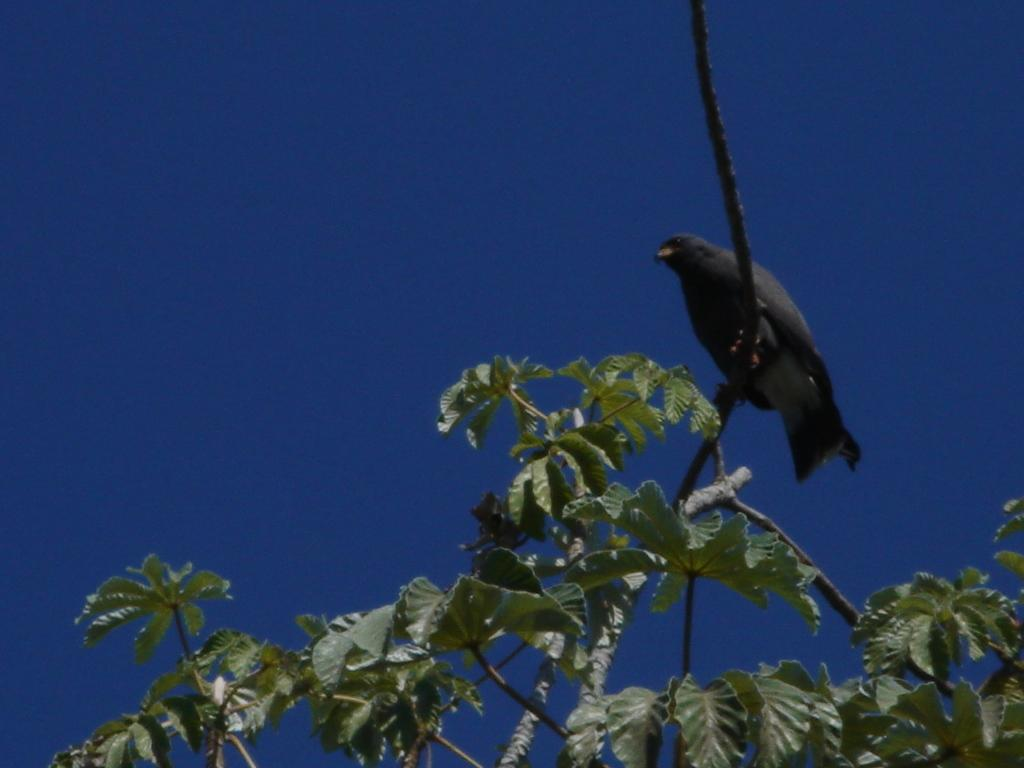What is present in the picture? There is a tree in the picture. How much of the tree can be seen? A part of the tree is visible. What else can be seen in the background? There is a gray bird in the background. What is the color of the sky in the picture? The sky is blue in color. What type of lettuce is being traded by the station in the image? There is no station, lettuce, or trade present in the image. 